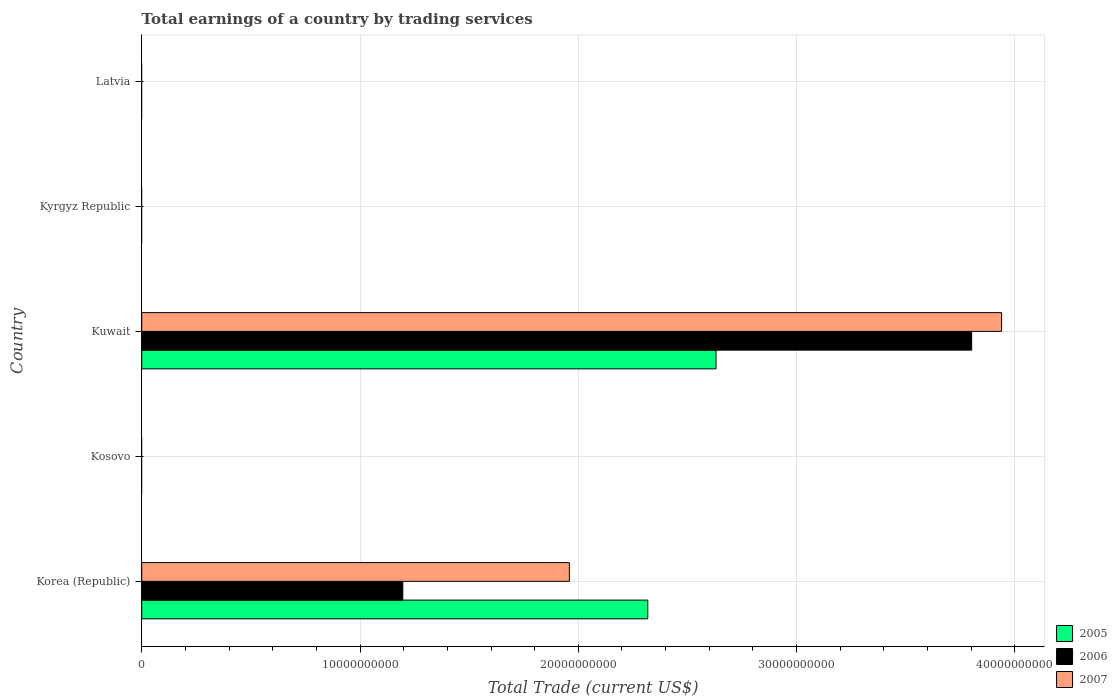Are the number of bars per tick equal to the number of legend labels?
Provide a succinct answer. No. What is the label of the 3rd group of bars from the top?
Offer a terse response. Kuwait. What is the total earnings in 2007 in Latvia?
Ensure brevity in your answer.  0. Across all countries, what is the maximum total earnings in 2007?
Provide a short and direct response. 3.94e+1. Across all countries, what is the minimum total earnings in 2007?
Provide a succinct answer. 0. In which country was the total earnings in 2007 maximum?
Provide a succinct answer. Kuwait. What is the total total earnings in 2007 in the graph?
Your answer should be very brief. 5.90e+1. What is the difference between the total earnings in 2006 in Korea (Republic) and that in Kuwait?
Ensure brevity in your answer.  -2.61e+1. What is the difference between the total earnings in 2006 in Kuwait and the total earnings in 2007 in Latvia?
Provide a succinct answer. 3.80e+1. What is the average total earnings in 2007 per country?
Make the answer very short. 1.18e+1. What is the difference between the total earnings in 2005 and total earnings in 2006 in Kuwait?
Provide a short and direct response. -1.17e+1. In how many countries, is the total earnings in 2007 greater than 20000000000 US$?
Offer a very short reply. 1. What is the ratio of the total earnings in 2006 in Korea (Republic) to that in Kuwait?
Give a very brief answer. 0.31. Is the difference between the total earnings in 2005 in Korea (Republic) and Kuwait greater than the difference between the total earnings in 2006 in Korea (Republic) and Kuwait?
Your answer should be very brief. Yes. What is the difference between the highest and the lowest total earnings in 2006?
Your answer should be very brief. 3.80e+1. Is the sum of the total earnings in 2007 in Korea (Republic) and Kuwait greater than the maximum total earnings in 2006 across all countries?
Provide a succinct answer. Yes. Is it the case that in every country, the sum of the total earnings in 2007 and total earnings in 2005 is greater than the total earnings in 2006?
Provide a short and direct response. No. How many bars are there?
Give a very brief answer. 6. Are all the bars in the graph horizontal?
Your response must be concise. Yes. Does the graph contain any zero values?
Provide a succinct answer. Yes. Does the graph contain grids?
Your answer should be very brief. Yes. Where does the legend appear in the graph?
Your answer should be compact. Bottom right. How are the legend labels stacked?
Your answer should be very brief. Vertical. What is the title of the graph?
Your answer should be compact. Total earnings of a country by trading services. What is the label or title of the X-axis?
Give a very brief answer. Total Trade (current US$). What is the Total Trade (current US$) in 2005 in Korea (Republic)?
Your answer should be very brief. 2.32e+1. What is the Total Trade (current US$) of 2006 in Korea (Republic)?
Give a very brief answer. 1.20e+1. What is the Total Trade (current US$) of 2007 in Korea (Republic)?
Your response must be concise. 1.96e+1. What is the Total Trade (current US$) in 2005 in Kosovo?
Your response must be concise. 0. What is the Total Trade (current US$) of 2006 in Kosovo?
Ensure brevity in your answer.  0. What is the Total Trade (current US$) of 2005 in Kuwait?
Your answer should be compact. 2.63e+1. What is the Total Trade (current US$) of 2006 in Kuwait?
Your response must be concise. 3.80e+1. What is the Total Trade (current US$) of 2007 in Kuwait?
Keep it short and to the point. 3.94e+1. What is the Total Trade (current US$) of 2006 in Kyrgyz Republic?
Provide a succinct answer. 0. What is the Total Trade (current US$) in 2007 in Latvia?
Make the answer very short. 0. Across all countries, what is the maximum Total Trade (current US$) in 2005?
Your answer should be very brief. 2.63e+1. Across all countries, what is the maximum Total Trade (current US$) of 2006?
Your answer should be very brief. 3.80e+1. Across all countries, what is the maximum Total Trade (current US$) of 2007?
Your answer should be very brief. 3.94e+1. What is the total Total Trade (current US$) of 2005 in the graph?
Ensure brevity in your answer.  4.95e+1. What is the total Total Trade (current US$) in 2006 in the graph?
Ensure brevity in your answer.  5.00e+1. What is the total Total Trade (current US$) of 2007 in the graph?
Your response must be concise. 5.90e+1. What is the difference between the Total Trade (current US$) of 2005 in Korea (Republic) and that in Kuwait?
Give a very brief answer. -3.13e+09. What is the difference between the Total Trade (current US$) in 2006 in Korea (Republic) and that in Kuwait?
Provide a short and direct response. -2.61e+1. What is the difference between the Total Trade (current US$) of 2007 in Korea (Republic) and that in Kuwait?
Provide a short and direct response. -1.98e+1. What is the difference between the Total Trade (current US$) of 2005 in Korea (Republic) and the Total Trade (current US$) of 2006 in Kuwait?
Ensure brevity in your answer.  -1.48e+1. What is the difference between the Total Trade (current US$) of 2005 in Korea (Republic) and the Total Trade (current US$) of 2007 in Kuwait?
Keep it short and to the point. -1.62e+1. What is the difference between the Total Trade (current US$) of 2006 in Korea (Republic) and the Total Trade (current US$) of 2007 in Kuwait?
Offer a very short reply. -2.74e+1. What is the average Total Trade (current US$) of 2005 per country?
Provide a short and direct response. 9.90e+09. What is the average Total Trade (current US$) of 2006 per country?
Keep it short and to the point. 1.00e+1. What is the average Total Trade (current US$) in 2007 per country?
Keep it short and to the point. 1.18e+1. What is the difference between the Total Trade (current US$) of 2005 and Total Trade (current US$) of 2006 in Korea (Republic)?
Offer a very short reply. 1.12e+1. What is the difference between the Total Trade (current US$) of 2005 and Total Trade (current US$) of 2007 in Korea (Republic)?
Keep it short and to the point. 3.59e+09. What is the difference between the Total Trade (current US$) of 2006 and Total Trade (current US$) of 2007 in Korea (Republic)?
Your answer should be compact. -7.63e+09. What is the difference between the Total Trade (current US$) of 2005 and Total Trade (current US$) of 2006 in Kuwait?
Make the answer very short. -1.17e+1. What is the difference between the Total Trade (current US$) in 2005 and Total Trade (current US$) in 2007 in Kuwait?
Ensure brevity in your answer.  -1.31e+1. What is the difference between the Total Trade (current US$) of 2006 and Total Trade (current US$) of 2007 in Kuwait?
Ensure brevity in your answer.  -1.37e+09. What is the ratio of the Total Trade (current US$) in 2005 in Korea (Republic) to that in Kuwait?
Ensure brevity in your answer.  0.88. What is the ratio of the Total Trade (current US$) of 2006 in Korea (Republic) to that in Kuwait?
Provide a short and direct response. 0.31. What is the ratio of the Total Trade (current US$) in 2007 in Korea (Republic) to that in Kuwait?
Offer a terse response. 0.5. What is the difference between the highest and the lowest Total Trade (current US$) in 2005?
Ensure brevity in your answer.  2.63e+1. What is the difference between the highest and the lowest Total Trade (current US$) in 2006?
Your answer should be very brief. 3.80e+1. What is the difference between the highest and the lowest Total Trade (current US$) in 2007?
Your response must be concise. 3.94e+1. 